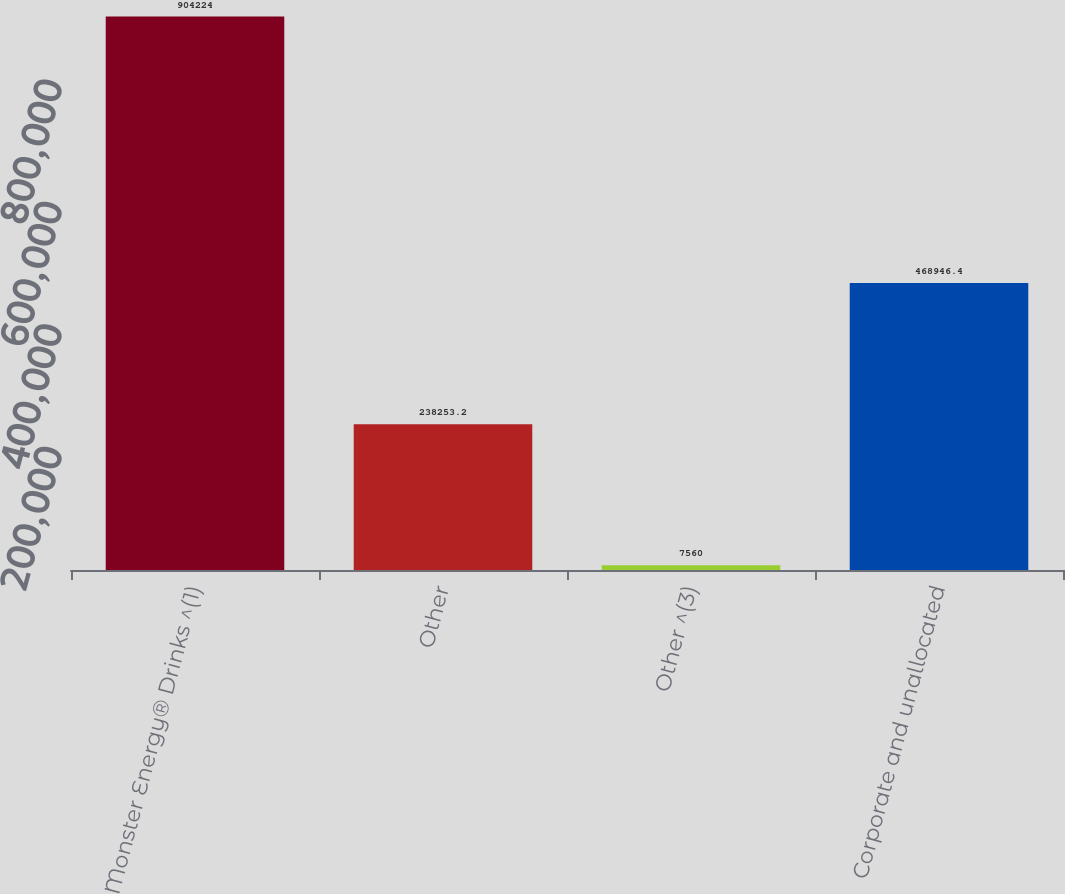Convert chart to OTSL. <chart><loc_0><loc_0><loc_500><loc_500><bar_chart><fcel>Monster Energy® Drinks ^(1)<fcel>Other<fcel>Other ^(3)<fcel>Corporate and unallocated<nl><fcel>904224<fcel>238253<fcel>7560<fcel>468946<nl></chart> 